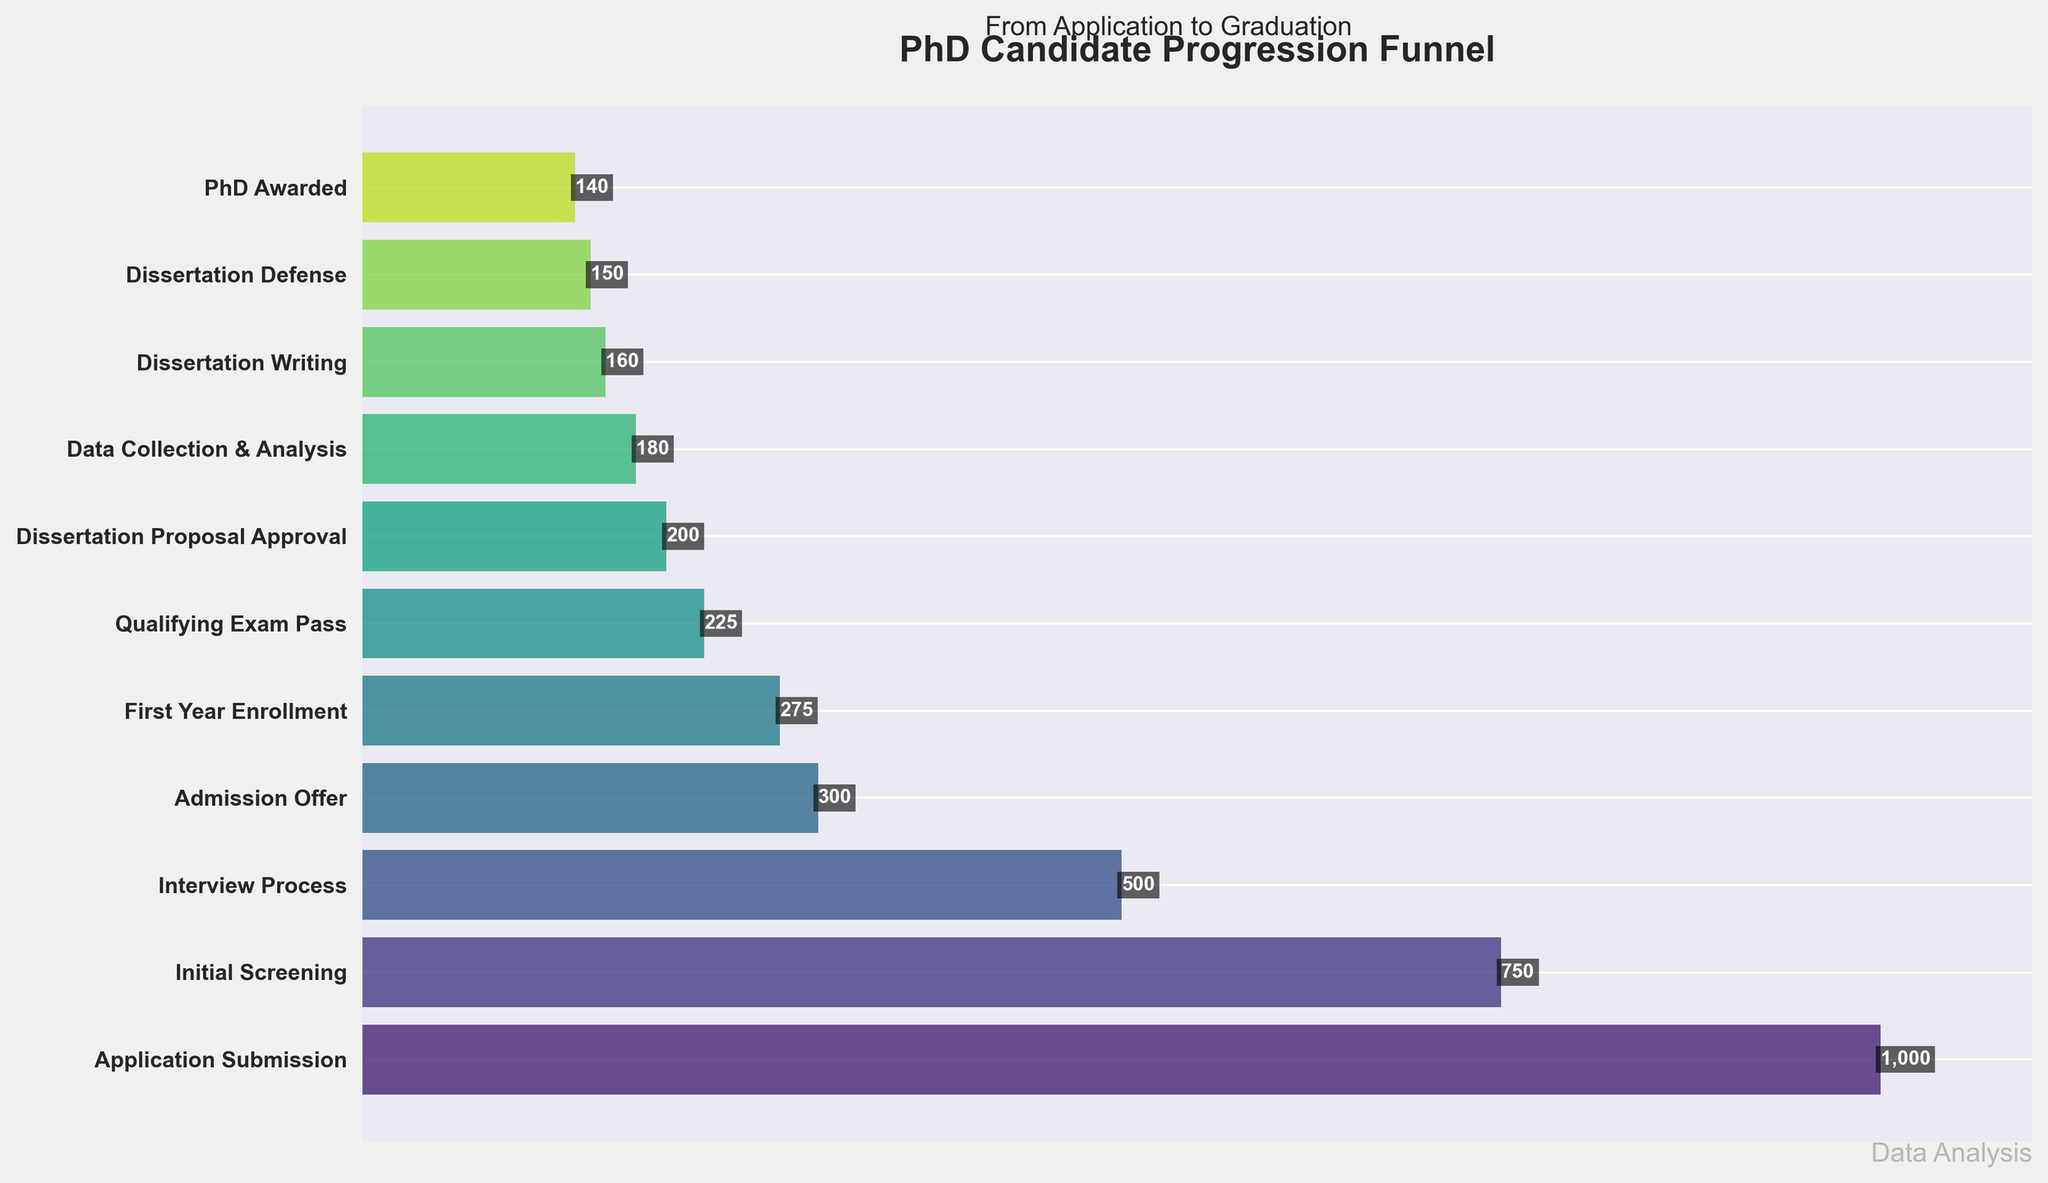What's the title of the figure? The title is typically placed at the top of the figure. In this case, it reads "PhD Candidate Progression Funnel".
Answer: PhD Candidate Progression Funnel Which stage has the highest number of candidates? The funnel chart displays the number of candidates at each stage in descending order. The first stage, "Application Submission", has the highest number of candidates.
Answer: Application Submission How many candidates pass the Qualifying Exam? Read the value next to the "Qualifying Exam Pass" label on the y-axis. The number next to it is 225.
Answer: 225 What is the candidate drop-off from Application Submission to Initial Screening? Subtract the number of candidates in the Initial Screening stage (750) from those in the Application Submission stage (1000).
Answer: 250 Which stage has a candidate number closest to 200? Look for the stage where the displayed number of candidates is closest to 200. In this case, it's "Dissertation Proposal Approval" with exactly 200 candidates.
Answer: Dissertation Proposal Approval How many candidates reach the Dissertation Defense stage? Find the value associated with the "Dissertation Defense" label on the y-axis. The number is 150.
Answer: 150 What's the percentage of candidates who receive an admission offer out of those who submitted an application? Divide the number of candidates in the Admission Offer stage (300) by the number of candidates in the Application Submission stage (1000) and multiply by 100 to get the percentage.
Answer: 30% How many candidates drop out between the Dissertation Proposal Approval and Data Collection & Analysis stages? Subtract the number of candidates in the Data Collection & Analysis stage (180) from the Dissertation Proposal Approval stage (200).
Answer: 20 What is the total candidate reduction from First Year Enrollment to PhD Awarded? Subtract the number of candidates in the PhD Awarded stage (140) from the First Year Enrollment stage (275).
Answer: 135 How many more candidates pass the Qualifying Exam compared to those who defend their dissertation? Subtract the number of candidates who defend their dissertation (150) from those who pass the Qualifying Exam (225).
Answer: 75 